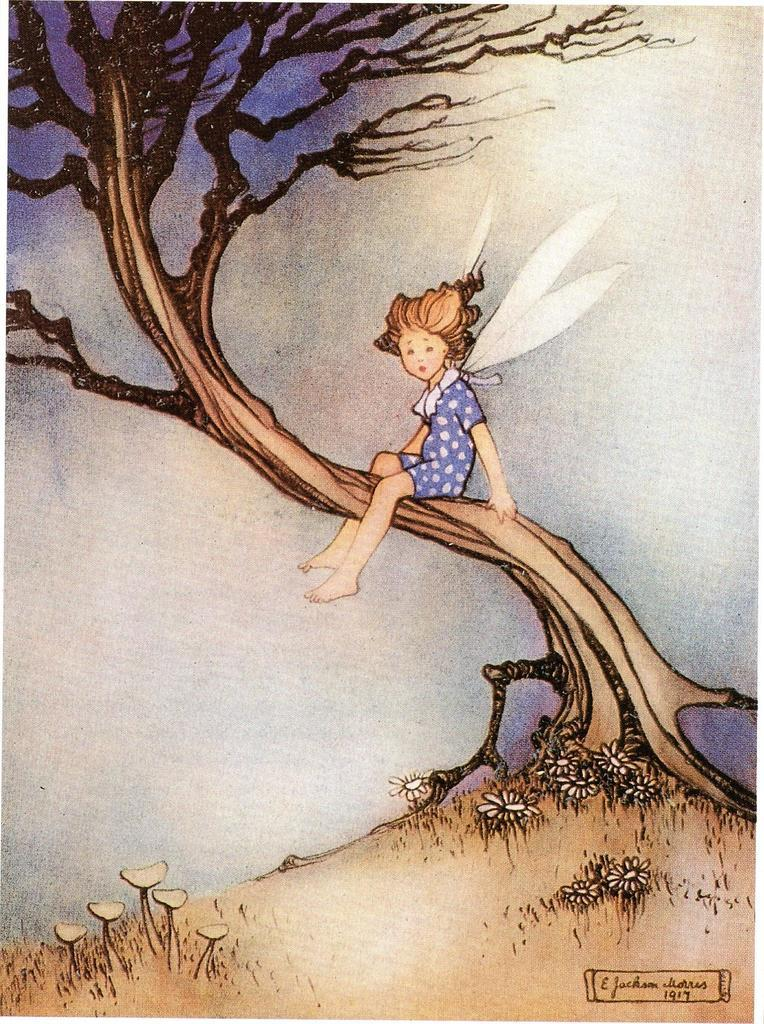What is the person in the image doing? The person is sitting on the branch of a tree in the image. What is the person wearing? The person is wearing a white and purple dress. What can be seen on the ground in the image? There are plants visible on the ground in the image. What type of pancake is the person holding in the image? There is no pancake present in the image; the person is sitting on a tree branch wearing a white and purple dress. What color is the button on the person's dress? The facts do not mention any buttons on the person's dress, only the colors white and purple. 